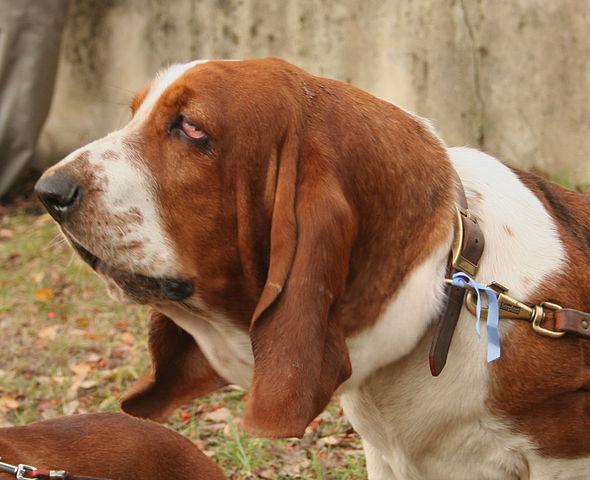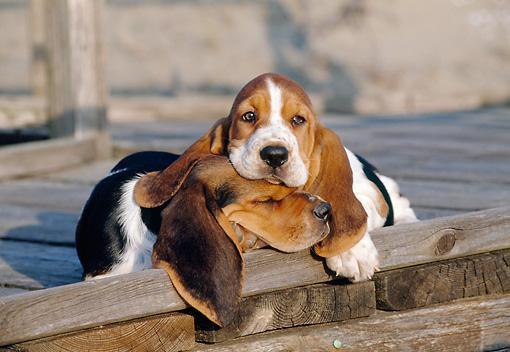The first image is the image on the left, the second image is the image on the right. For the images shown, is this caption "At least one dog is cuddling with a furry friend." true? Answer yes or no. Yes. The first image is the image on the left, the second image is the image on the right. Evaluate the accuracy of this statement regarding the images: "a dog has his head on a pillow". Is it true? Answer yes or no. No. 